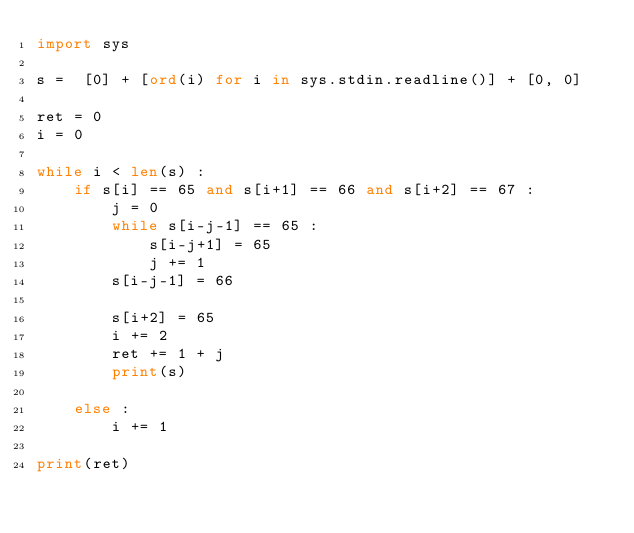Convert code to text. <code><loc_0><loc_0><loc_500><loc_500><_Python_>import sys

s =  [0] + [ord(i) for i in sys.stdin.readline()] + [0, 0]

ret = 0
i = 0

while i < len(s) :
    if s[i] == 65 and s[i+1] == 66 and s[i+2] == 67 :
        j = 0
        while s[i-j-1] == 65 :
            s[i-j+1] = 65
            j += 1
        s[i-j-1] = 66

        s[i+2] = 65
        i += 2
        ret += 1 + j
        print(s)
        
    else :
        i += 1

print(ret)
</code> 